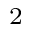Convert formula to latex. <formula><loc_0><loc_0><loc_500><loc_500>^ { 2 }</formula> 